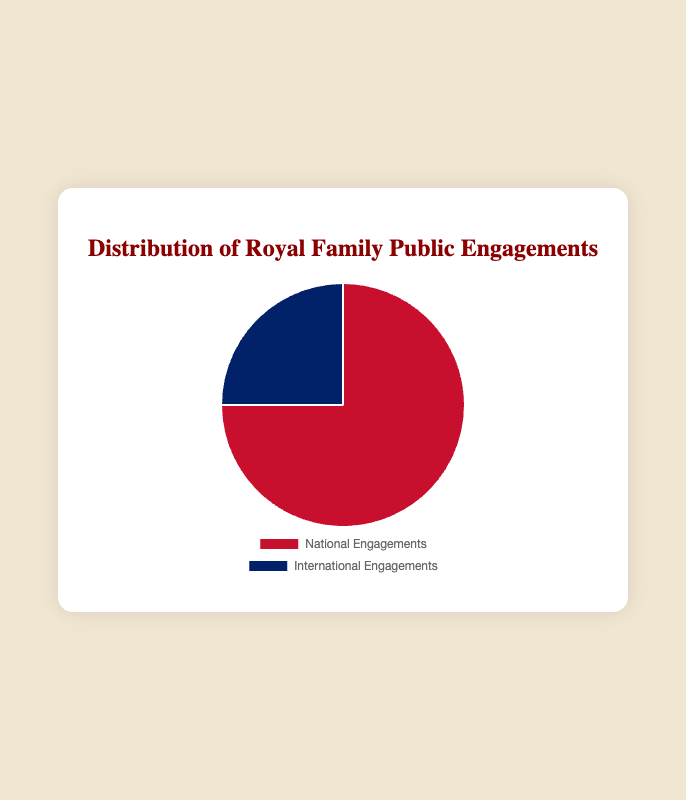What percentage of the royal family's public engagements are national? The pie chart shows two segments: one representing national engagements and another representing international engagements. The size of the national segment represents 75% of the total.
Answer: 75% What percentage of the royal family's public engagements are international? The pie chart shows that the segment for international engagements makes up 25% of the total engagements.
Answer: 25% How much larger are national engagements compared to international engagements? The chart shows national engagements at 75% and international at 25%. Subtract 25% from 75% to find the difference.
Answer: 50% What is the ratio of national to international engagements? The pie chart indicates that national engagements comprise 75% and international 25%. To find the ratio, divide 75 by 25, resulting in a ratio of 3:1.
Answer: 3:1 If we combine both categories, what is the total number of engagements represented on the pie chart? The pie chart shows percentages totaling 100%. Adding the national (75%) and international (25%) engagements confirms that the total is 100%.
Answer: 100% Which type of engagements occurs less frequently, and by what visual attribute can you deduce this? The pie chart's international engagements are smaller than national engagements. This deduction is based on the smaller segment's size and different color (blue).
Answer: International, smaller segment By what factor must the percentage of international engagements be increased to equal the percentage of national engagements? The chart shows international engagements at 25% and national at 75%. To equalize, divide 75 by 25, resulting in a factor of 3.
Answer: Factor of 3 What is the combined proportion of the engagements conducted nationally? The pie chart directly displays that all national engagements constitute 75% of the total engagements.
Answer: 75% What color represents national engagements in the pie chart? The chart uses a specific color to differentiate each type of engagement. National engagements are shown in red.
Answer: Red Considering the visual representation, is the proportion of international engagements closer to 20% or 30%? The pie chart precisely marks the international segment as 25%, which is equidistant but slightly closer to 30% than 20%.
Answer: Closer to 30% 